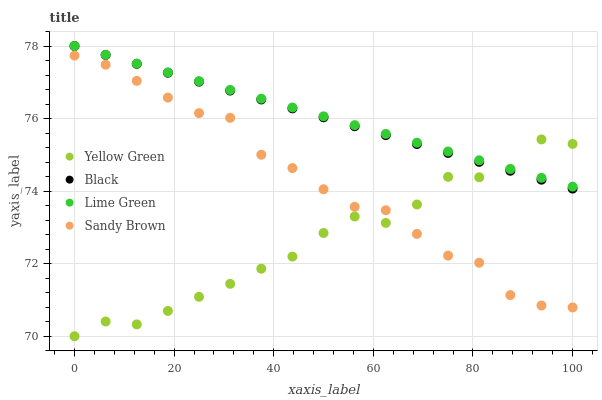Does Yellow Green have the minimum area under the curve?
Answer yes or no. Yes. Does Lime Green have the maximum area under the curve?
Answer yes or no. Yes. Does Black have the minimum area under the curve?
Answer yes or no. No. Does Black have the maximum area under the curve?
Answer yes or no. No. Is Lime Green the smoothest?
Answer yes or no. Yes. Is Yellow Green the roughest?
Answer yes or no. Yes. Is Black the smoothest?
Answer yes or no. No. Is Black the roughest?
Answer yes or no. No. Does Yellow Green have the lowest value?
Answer yes or no. Yes. Does Black have the lowest value?
Answer yes or no. No. Does Black have the highest value?
Answer yes or no. Yes. Does Yellow Green have the highest value?
Answer yes or no. No. Is Sandy Brown less than Lime Green?
Answer yes or no. Yes. Is Lime Green greater than Sandy Brown?
Answer yes or no. Yes. Does Yellow Green intersect Lime Green?
Answer yes or no. Yes. Is Yellow Green less than Lime Green?
Answer yes or no. No. Is Yellow Green greater than Lime Green?
Answer yes or no. No. Does Sandy Brown intersect Lime Green?
Answer yes or no. No. 